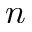Convert formula to latex. <formula><loc_0><loc_0><loc_500><loc_500>n</formula> 